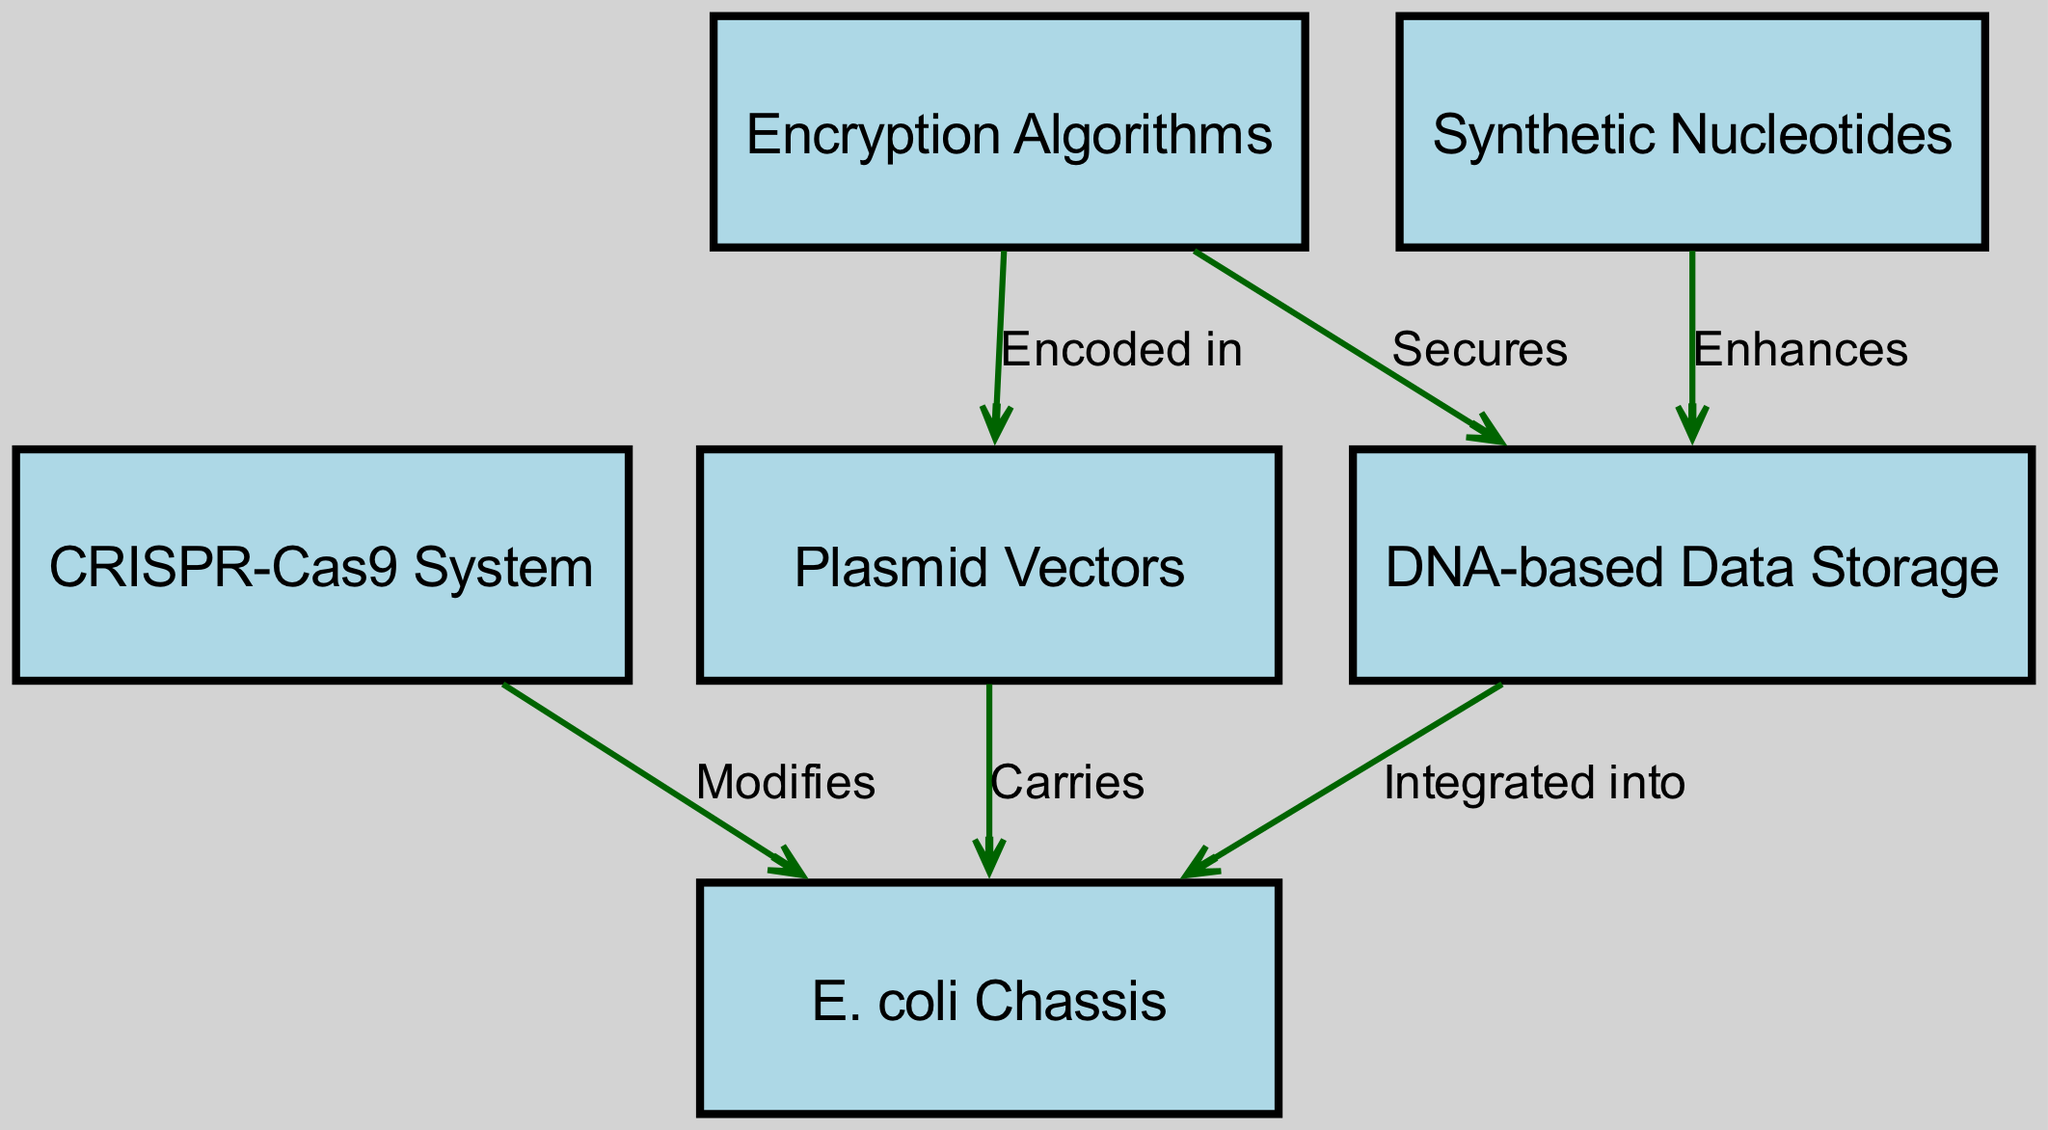What is the total number of nodes in the diagram? The diagram lists six distinct elements, each represented as a node in the structure, thus counting them shows there are six nodes total.
Answer: six Which node is integrated into the E. coli chassis? The diagram clearly states that the DNA-based data storage is the component that is integrated into the E. coli chassis.
Answer: DNA-based Data Storage What labels the relationship between the CRISPR-Cas9 system and the E. coli chassis? The edge pointing from the CRISPR-Cas9 system to the E. coli chassis is labeled "Modifies," indicating how one influences the other.
Answer: Modifies How many edges connect the synthetic nucleotides? The synthetic nucleotides have a direct connection to the DNA-based data storage node only, which means there is one edge related to them.
Answer: one What is the purpose of the encryption algorithms in this diagram? The encryption algorithms are designed to secure the DNA-based data storage, indicating a protective role in the overall structure.
Answer: Secures Which node carries plasmid vectors? The E. coli chassis node is connected to the plasmid vectors through a labeled edge indicating that it carries them.
Answer: E. coli Chassis What role does the synthetic nucleotide play in this diagram? According to the diagram, the synthetic nucleotide enhances DNA-based data storage, which pinpoints their functional contribution.
Answer: Enhances What is encoded in plasmid vectors according to the diagram? The relationship shows that encryption algorithms are encoded in the plasmid vectors, indicating that these two components are directly linked.
Answer: Encoded in What is the relationship between the encryption algorithms and the DNA-based data storage? The diagram indicates that the encryption algorithms serve to secure the DNA-based data storage, showing how they work together.
Answer: Secures 